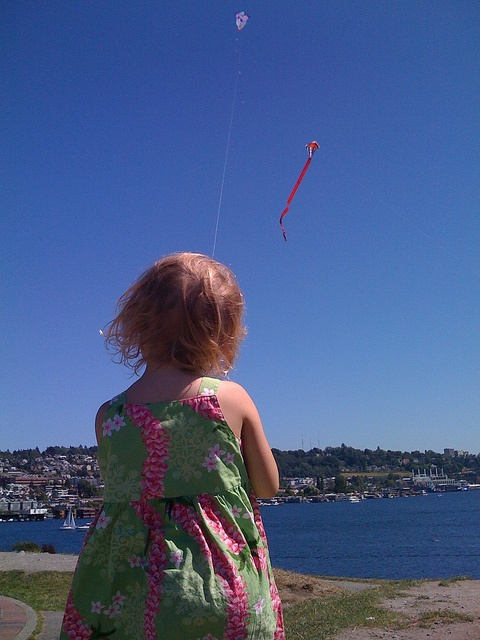Describe the objects in this image and their specific colors. I can see people in darkblue, black, maroon, gray, and purple tones, kite in darkblue, brown, blue, and purple tones, kite in darkblue, blue, violet, and gray tones, boat in darkblue, gray, and navy tones, and boat in darkblue, gray, navy, darkgray, and black tones in this image. 